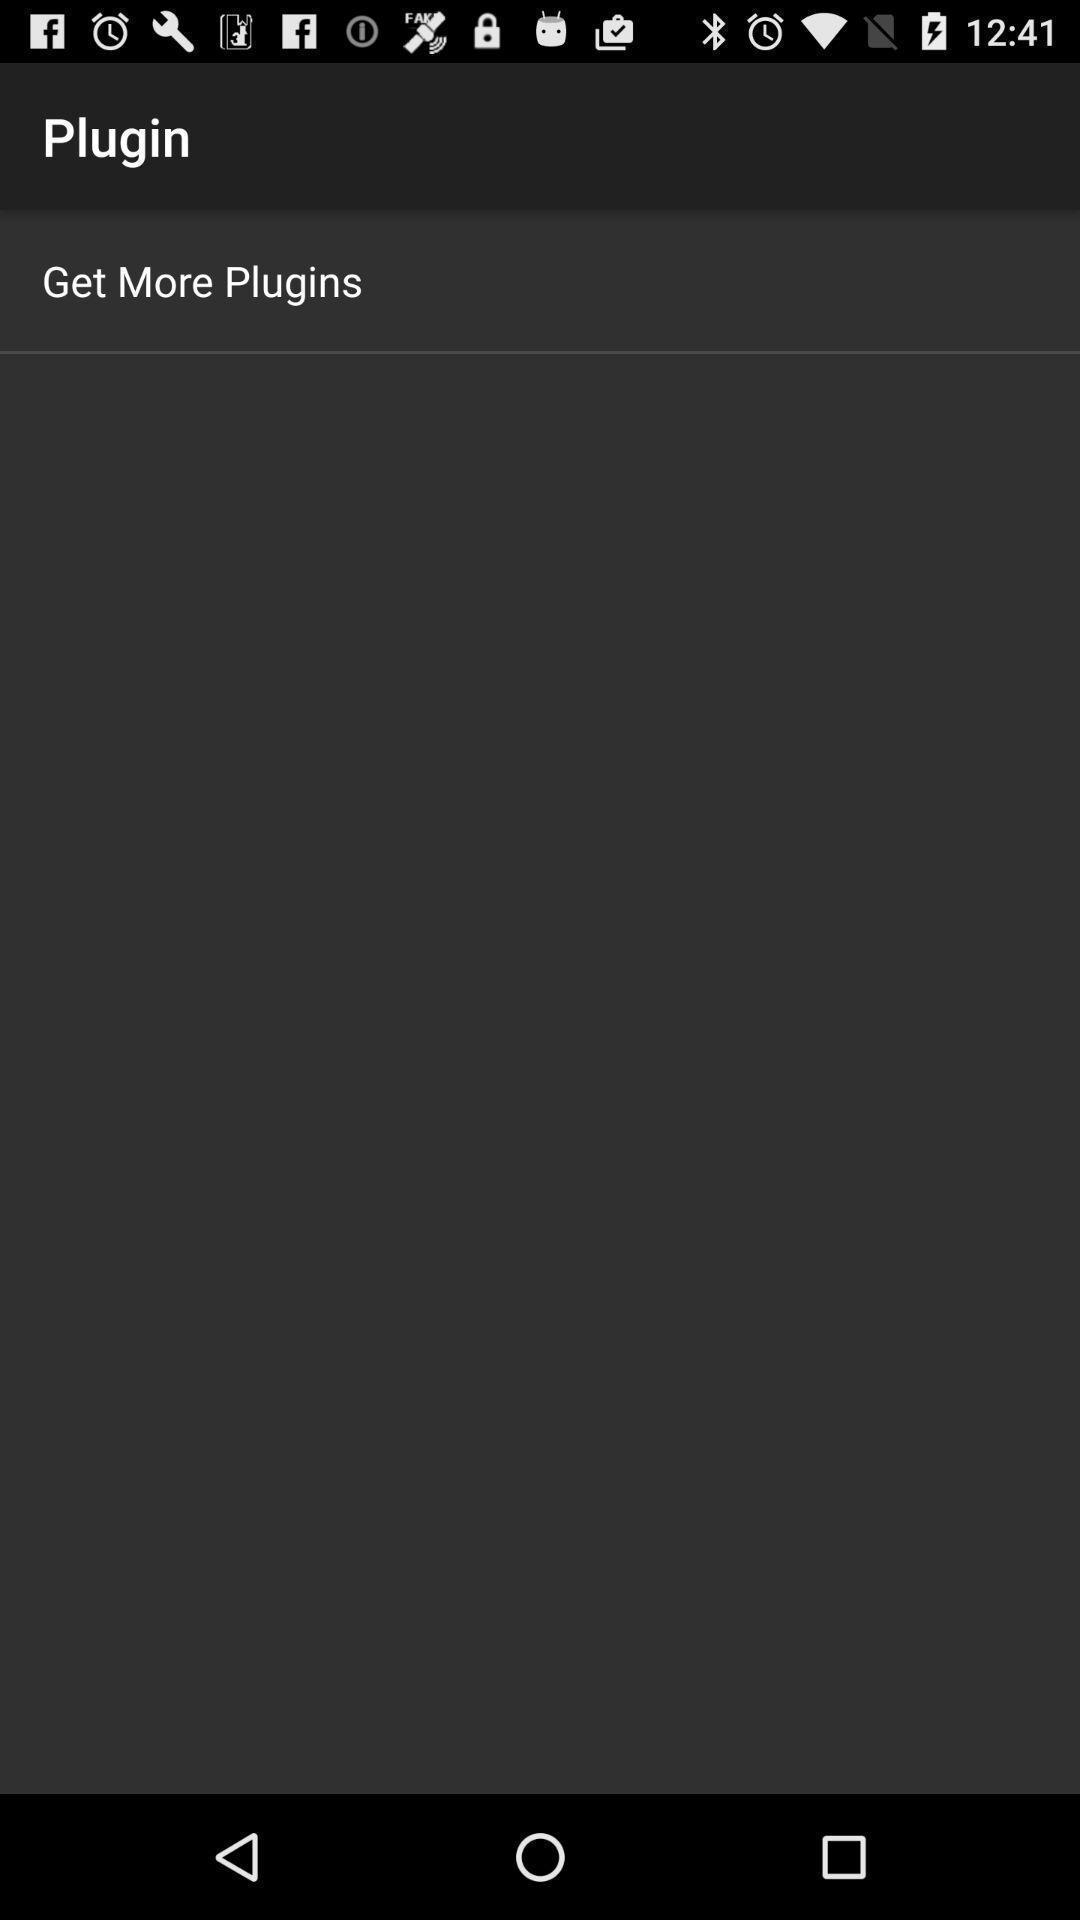Tell me what you see in this picture. Screen showing to get more plugins. 